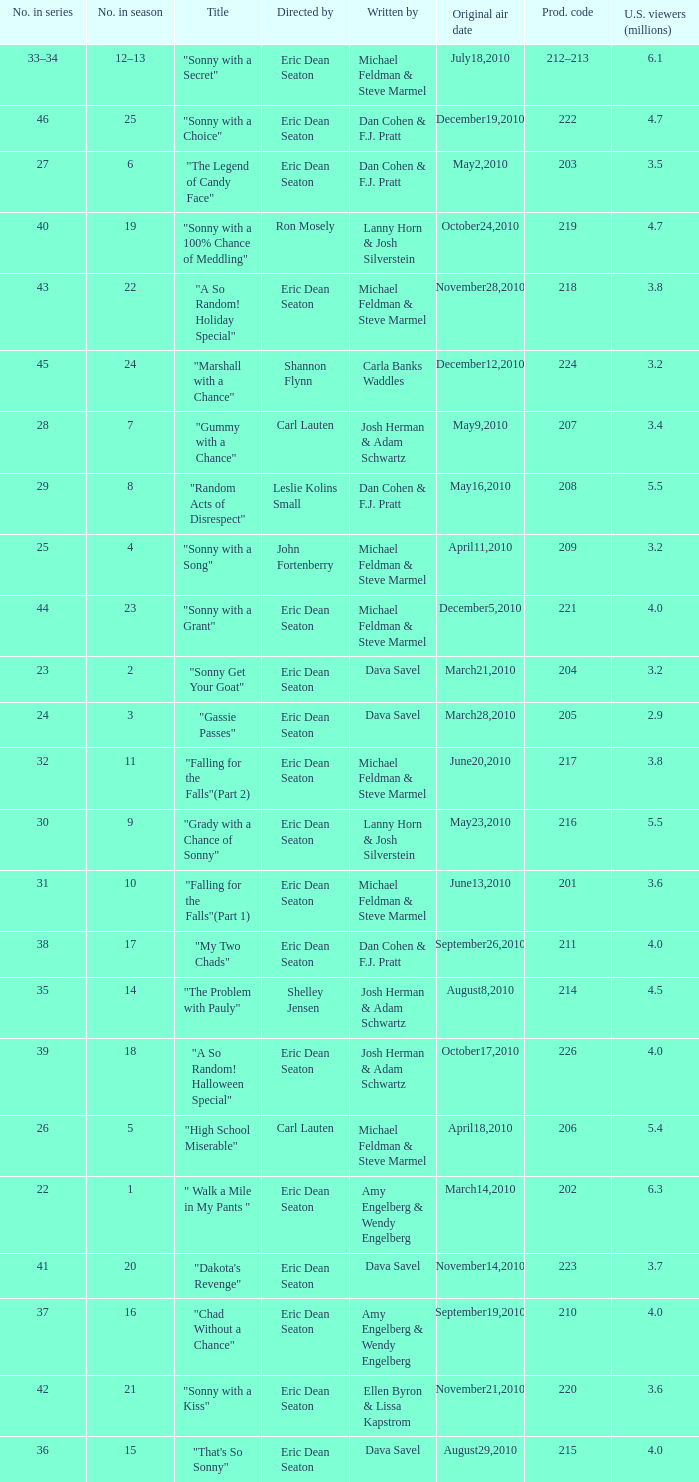How man episodes in the season were titled "that's so sonny"? 1.0. 